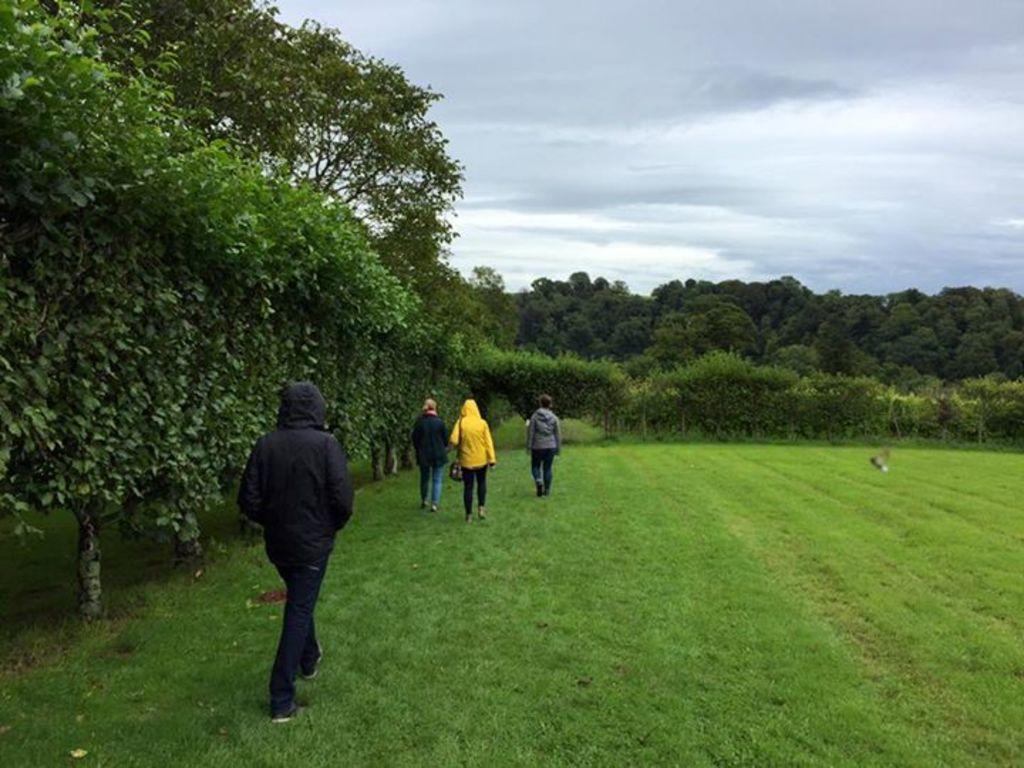How would you summarize this image in a sentence or two? This picture is taken from the outside of the city. In this image, on the left side, we can see a group of people are walking on the grass. On the left side, we can see some trees and plants. In the background, we can see some plants, trees. At the top, we can see a sky which is cloudy, at the bottom, we can see a grass. 